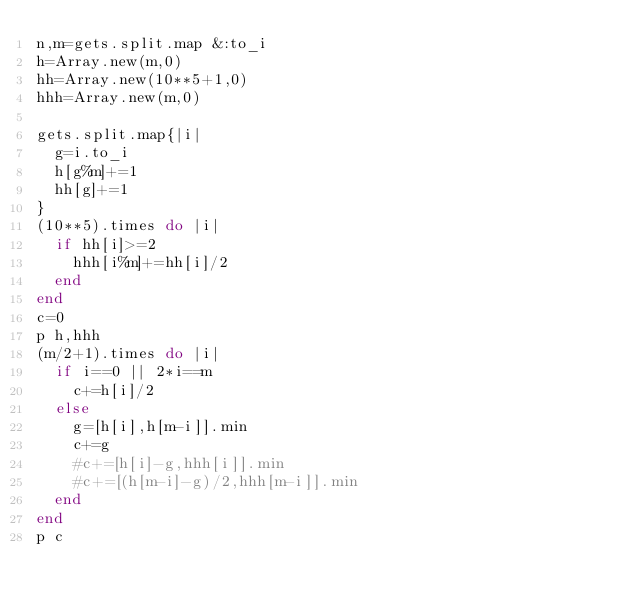Convert code to text. <code><loc_0><loc_0><loc_500><loc_500><_Ruby_>n,m=gets.split.map &:to_i
h=Array.new(m,0)
hh=Array.new(10**5+1,0)
hhh=Array.new(m,0)

gets.split.map{|i|
  g=i.to_i
  h[g%m]+=1
  hh[g]+=1
}
(10**5).times do |i|
  if hh[i]>=2
    hhh[i%m]+=hh[i]/2
  end
end
c=0
p h,hhh
(m/2+1).times do |i|
  if i==0 || 2*i==m
    c+=h[i]/2
  else
    g=[h[i],h[m-i]].min
    c+=g
    #c+=[h[i]-g,hhh[i]].min
    #c+=[(h[m-i]-g)/2,hhh[m-i]].min
  end
end
p c</code> 